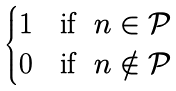Convert formula to latex. <formula><loc_0><loc_0><loc_500><loc_500>\begin{cases} 1 & \text {if } \ n \in \mathcal { P } \\ 0 & \text {if } \ n \notin \mathcal { P } \end{cases}</formula> 